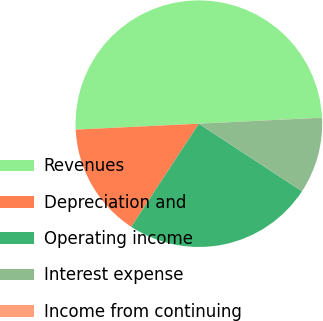Convert chart. <chart><loc_0><loc_0><loc_500><loc_500><pie_chart><fcel>Revenues<fcel>Depreciation and<fcel>Operating income<fcel>Interest expense<fcel>Income from continuing<nl><fcel>49.98%<fcel>15.0%<fcel>25.0%<fcel>10.01%<fcel>0.01%<nl></chart> 